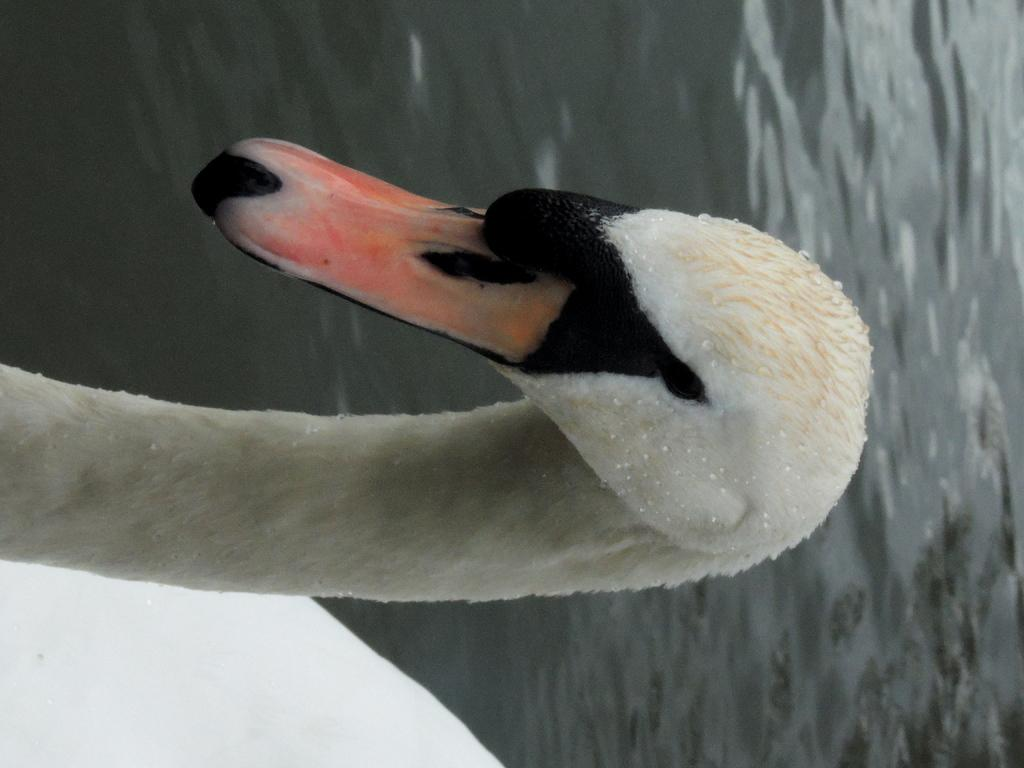What type of animal is in the image? There is a bird in the image. What colors can be seen on the bird? The bird has white, black, and orange colors. What is visible in the background of the image? There is water visible in the image. What book is the bird reading in the image? There is no book or reading activity present in the image; it features a bird in its natural environment. 